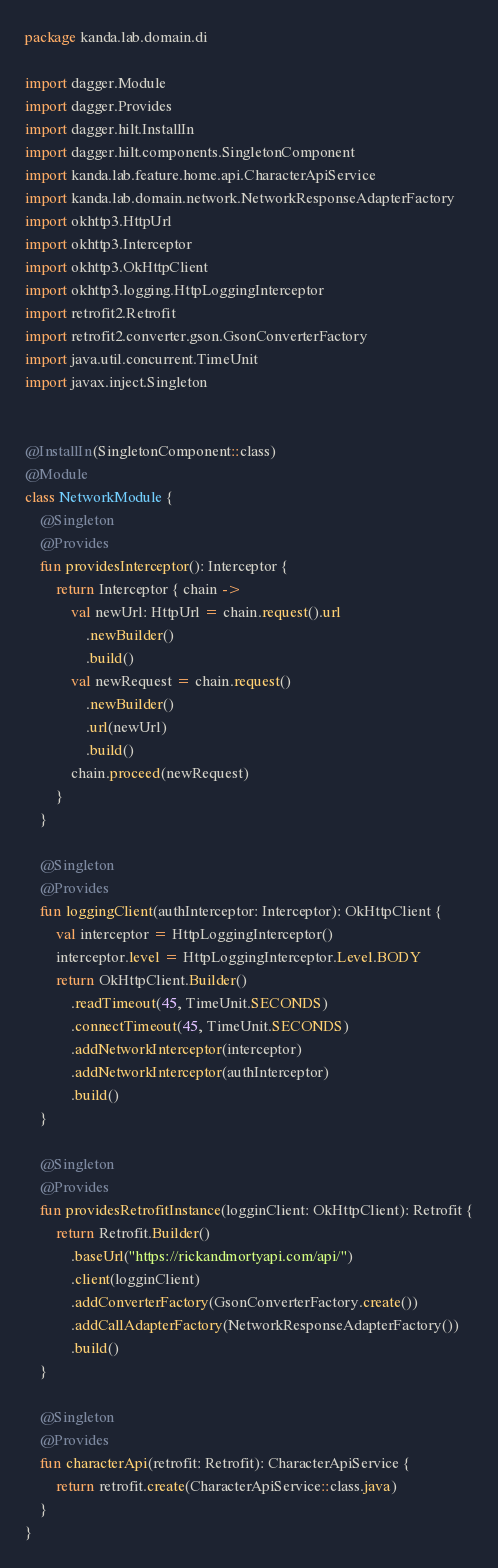<code> <loc_0><loc_0><loc_500><loc_500><_Kotlin_>package kanda.lab.domain.di

import dagger.Module
import dagger.Provides
import dagger.hilt.InstallIn
import dagger.hilt.components.SingletonComponent
import kanda.lab.feature.home.api.CharacterApiService
import kanda.lab.domain.network.NetworkResponseAdapterFactory
import okhttp3.HttpUrl
import okhttp3.Interceptor
import okhttp3.OkHttpClient
import okhttp3.logging.HttpLoggingInterceptor
import retrofit2.Retrofit
import retrofit2.converter.gson.GsonConverterFactory
import java.util.concurrent.TimeUnit
import javax.inject.Singleton


@InstallIn(SingletonComponent::class)
@Module
class NetworkModule {
    @Singleton
    @Provides
    fun providesInterceptor(): Interceptor {
        return Interceptor { chain ->
            val newUrl: HttpUrl = chain.request().url
                .newBuilder()
                .build()
            val newRequest = chain.request()
                .newBuilder()
                .url(newUrl)
                .build()
            chain.proceed(newRequest)
        }
    }

    @Singleton
    @Provides
    fun loggingClient(authInterceptor: Interceptor): OkHttpClient {
        val interceptor = HttpLoggingInterceptor()
        interceptor.level = HttpLoggingInterceptor.Level.BODY
        return OkHttpClient.Builder()
            .readTimeout(45, TimeUnit.SECONDS)
            .connectTimeout(45, TimeUnit.SECONDS)
            .addNetworkInterceptor(interceptor)
            .addNetworkInterceptor(authInterceptor)
            .build()
    }

    @Singleton
    @Provides
    fun providesRetrofitInstance(logginClient: OkHttpClient): Retrofit {
        return Retrofit.Builder()
            .baseUrl("https://rickandmortyapi.com/api/")
            .client(logginClient)
            .addConverterFactory(GsonConverterFactory.create())
            .addCallAdapterFactory(NetworkResponseAdapterFactory())
            .build()
    }

    @Singleton
    @Provides
    fun characterApi(retrofit: Retrofit): CharacterApiService {
        return retrofit.create(CharacterApiService::class.java)
    }
}</code> 